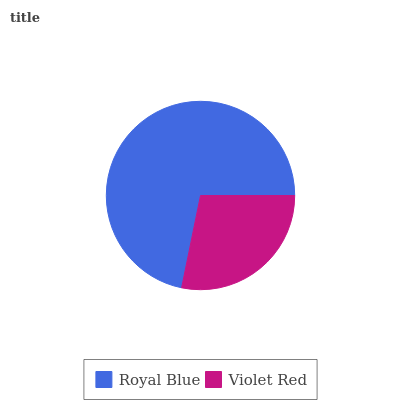Is Violet Red the minimum?
Answer yes or no. Yes. Is Royal Blue the maximum?
Answer yes or no. Yes. Is Violet Red the maximum?
Answer yes or no. No. Is Royal Blue greater than Violet Red?
Answer yes or no. Yes. Is Violet Red less than Royal Blue?
Answer yes or no. Yes. Is Violet Red greater than Royal Blue?
Answer yes or no. No. Is Royal Blue less than Violet Red?
Answer yes or no. No. Is Royal Blue the high median?
Answer yes or no. Yes. Is Violet Red the low median?
Answer yes or no. Yes. Is Violet Red the high median?
Answer yes or no. No. Is Royal Blue the low median?
Answer yes or no. No. 